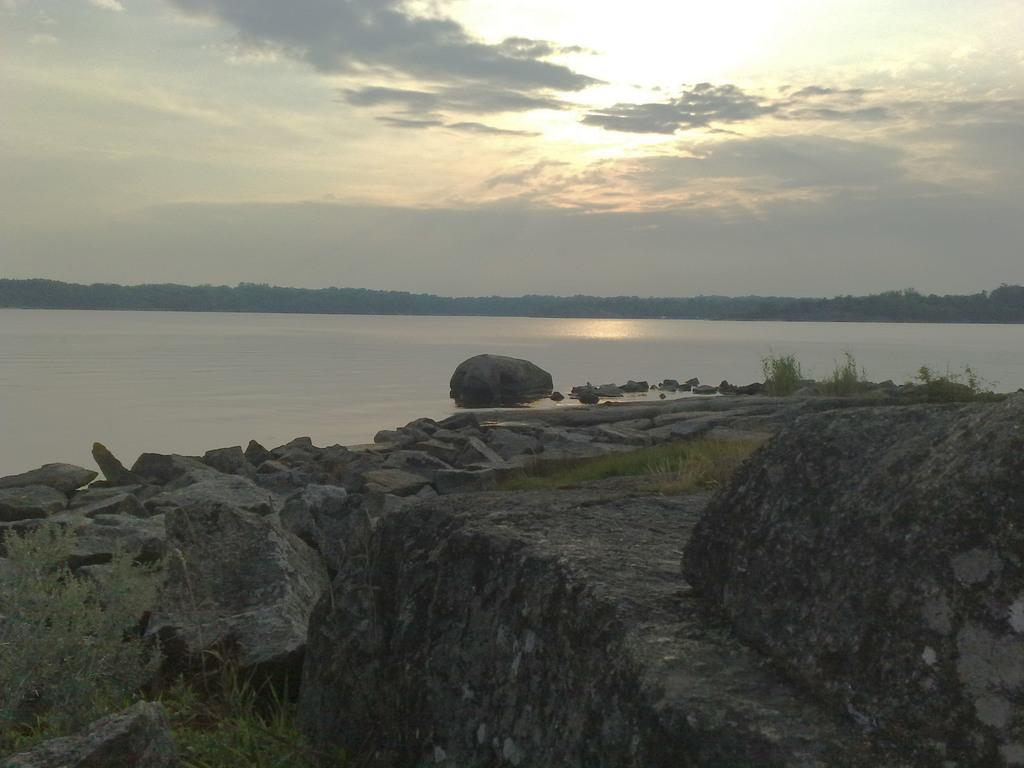What type of natural elements can be seen in the image? There are rocks and plants visible in the image. What can be seen in the background of the image? There is a river, trees, and the sky visible in the background of the image. How many dogs are playing with the daughter in the image? There are no dogs or a daughter present in the image. 